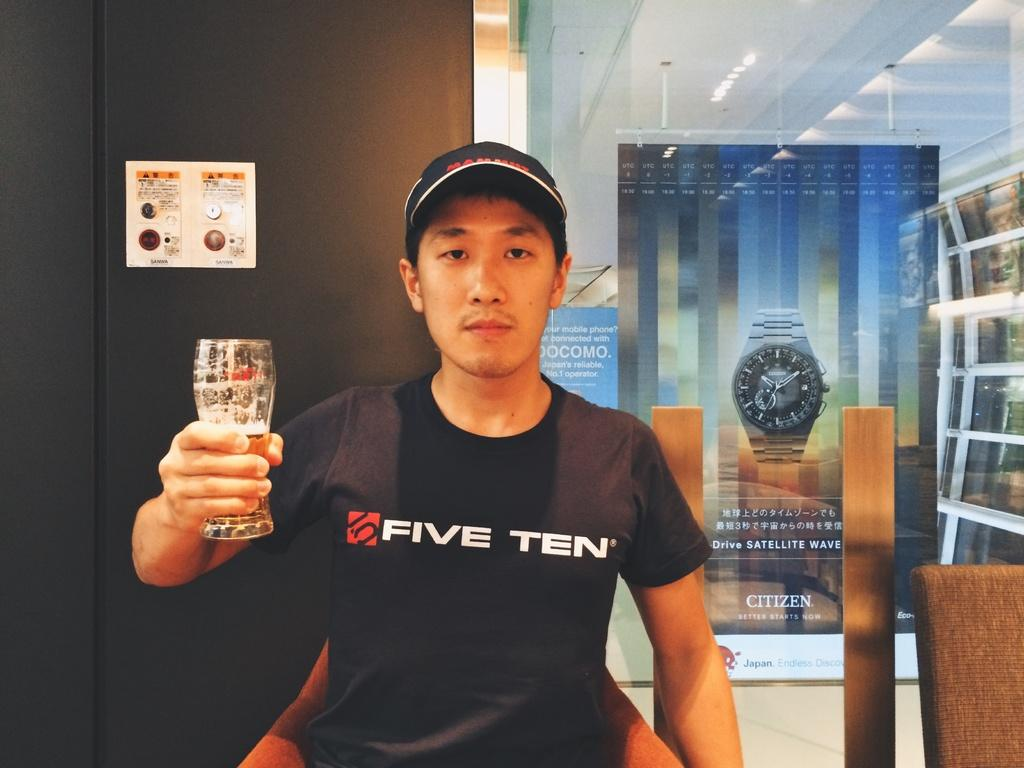<image>
Offer a succinct explanation of the picture presented. A man in a Five Ten shirt is holding a glass. 